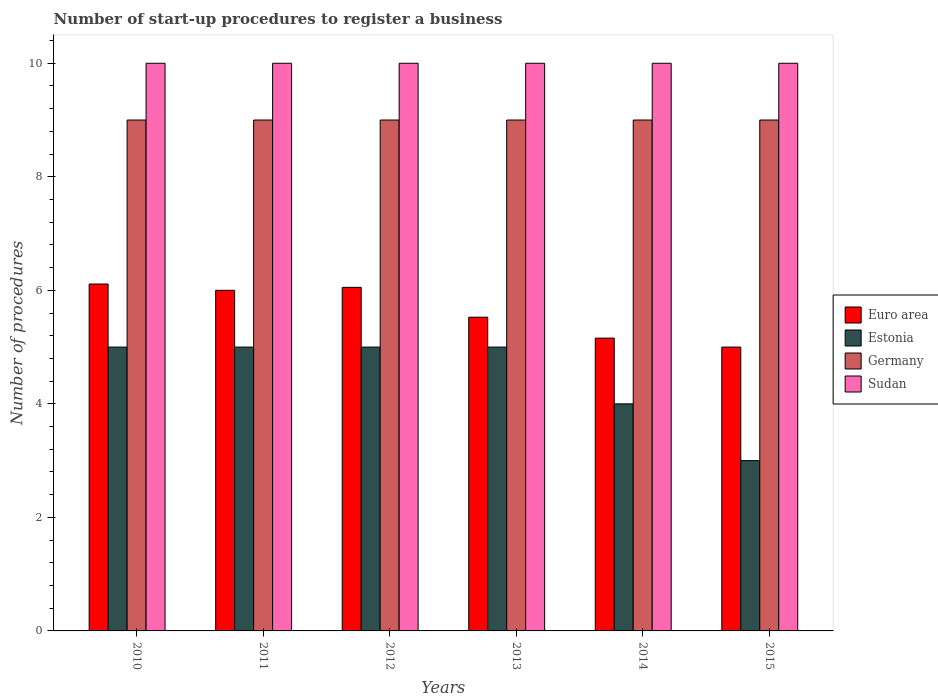How many different coloured bars are there?
Provide a succinct answer. 4. How many groups of bars are there?
Your response must be concise. 6. How many bars are there on the 1st tick from the right?
Ensure brevity in your answer.  4. What is the label of the 1st group of bars from the left?
Offer a terse response. 2010. What is the number of procedures required to register a business in Germany in 2010?
Ensure brevity in your answer.  9. Across all years, what is the maximum number of procedures required to register a business in Germany?
Your response must be concise. 9. In which year was the number of procedures required to register a business in Euro area minimum?
Provide a short and direct response. 2015. What is the total number of procedures required to register a business in Euro area in the graph?
Offer a terse response. 33.85. What is the difference between the number of procedures required to register a business in Germany in 2011 and that in 2014?
Your answer should be compact. 0. What is the average number of procedures required to register a business in Euro area per year?
Your response must be concise. 5.64. In the year 2014, what is the difference between the number of procedures required to register a business in Sudan and number of procedures required to register a business in Euro area?
Offer a terse response. 4.84. In how many years, is the number of procedures required to register a business in Euro area greater than 4.4?
Offer a very short reply. 6. Is the difference between the number of procedures required to register a business in Sudan in 2012 and 2015 greater than the difference between the number of procedures required to register a business in Euro area in 2012 and 2015?
Offer a terse response. No. What is the difference between the highest and the second highest number of procedures required to register a business in Estonia?
Offer a very short reply. 0. Is the sum of the number of procedures required to register a business in Germany in 2010 and 2011 greater than the maximum number of procedures required to register a business in Sudan across all years?
Offer a terse response. Yes. Is it the case that in every year, the sum of the number of procedures required to register a business in Estonia and number of procedures required to register a business in Germany is greater than the sum of number of procedures required to register a business in Euro area and number of procedures required to register a business in Sudan?
Offer a very short reply. Yes. Is it the case that in every year, the sum of the number of procedures required to register a business in Estonia and number of procedures required to register a business in Germany is greater than the number of procedures required to register a business in Sudan?
Your answer should be compact. Yes. Are all the bars in the graph horizontal?
Keep it short and to the point. No. How many years are there in the graph?
Your answer should be very brief. 6. Are the values on the major ticks of Y-axis written in scientific E-notation?
Keep it short and to the point. No. Does the graph contain grids?
Give a very brief answer. No. How many legend labels are there?
Offer a very short reply. 4. What is the title of the graph?
Provide a short and direct response. Number of start-up procedures to register a business. Does "Yemen, Rep." appear as one of the legend labels in the graph?
Your response must be concise. No. What is the label or title of the Y-axis?
Give a very brief answer. Number of procedures. What is the Number of procedures in Euro area in 2010?
Provide a succinct answer. 6.11. What is the Number of procedures of Germany in 2010?
Keep it short and to the point. 9. What is the Number of procedures in Estonia in 2011?
Your answer should be very brief. 5. What is the Number of procedures of Germany in 2011?
Ensure brevity in your answer.  9. What is the Number of procedures of Sudan in 2011?
Offer a terse response. 10. What is the Number of procedures in Euro area in 2012?
Make the answer very short. 6.05. What is the Number of procedures of Estonia in 2012?
Offer a terse response. 5. What is the Number of procedures of Sudan in 2012?
Your answer should be very brief. 10. What is the Number of procedures of Euro area in 2013?
Offer a very short reply. 5.53. What is the Number of procedures in Estonia in 2013?
Offer a terse response. 5. What is the Number of procedures in Germany in 2013?
Provide a short and direct response. 9. What is the Number of procedures in Euro area in 2014?
Keep it short and to the point. 5.16. What is the Number of procedures in Germany in 2014?
Offer a very short reply. 9. What is the Number of procedures in Sudan in 2014?
Give a very brief answer. 10. What is the Number of procedures in Euro area in 2015?
Your answer should be very brief. 5. What is the Number of procedures of Estonia in 2015?
Provide a succinct answer. 3. What is the Number of procedures of Germany in 2015?
Make the answer very short. 9. Across all years, what is the maximum Number of procedures of Euro area?
Provide a short and direct response. 6.11. Across all years, what is the maximum Number of procedures of Estonia?
Ensure brevity in your answer.  5. Across all years, what is the maximum Number of procedures of Germany?
Offer a terse response. 9. Across all years, what is the maximum Number of procedures in Sudan?
Keep it short and to the point. 10. Across all years, what is the minimum Number of procedures in Sudan?
Offer a terse response. 10. What is the total Number of procedures of Euro area in the graph?
Provide a succinct answer. 33.85. What is the total Number of procedures in Estonia in the graph?
Ensure brevity in your answer.  27. What is the total Number of procedures of Sudan in the graph?
Make the answer very short. 60. What is the difference between the Number of procedures of Sudan in 2010 and that in 2011?
Your response must be concise. 0. What is the difference between the Number of procedures in Euro area in 2010 and that in 2012?
Make the answer very short. 0.06. What is the difference between the Number of procedures in Estonia in 2010 and that in 2012?
Offer a very short reply. 0. What is the difference between the Number of procedures in Sudan in 2010 and that in 2012?
Offer a terse response. 0. What is the difference between the Number of procedures of Euro area in 2010 and that in 2013?
Provide a short and direct response. 0.58. What is the difference between the Number of procedures of Germany in 2010 and that in 2013?
Make the answer very short. 0. What is the difference between the Number of procedures of Euro area in 2010 and that in 2014?
Provide a short and direct response. 0.95. What is the difference between the Number of procedures of Estonia in 2010 and that in 2014?
Your answer should be compact. 1. What is the difference between the Number of procedures in Germany in 2010 and that in 2014?
Provide a succinct answer. 0. What is the difference between the Number of procedures in Estonia in 2010 and that in 2015?
Ensure brevity in your answer.  2. What is the difference between the Number of procedures of Germany in 2010 and that in 2015?
Your answer should be very brief. 0. What is the difference between the Number of procedures in Sudan in 2010 and that in 2015?
Your answer should be very brief. 0. What is the difference between the Number of procedures in Euro area in 2011 and that in 2012?
Provide a succinct answer. -0.05. What is the difference between the Number of procedures in Estonia in 2011 and that in 2012?
Make the answer very short. 0. What is the difference between the Number of procedures in Germany in 2011 and that in 2012?
Ensure brevity in your answer.  0. What is the difference between the Number of procedures of Sudan in 2011 and that in 2012?
Keep it short and to the point. 0. What is the difference between the Number of procedures of Euro area in 2011 and that in 2013?
Offer a very short reply. 0.47. What is the difference between the Number of procedures in Sudan in 2011 and that in 2013?
Provide a short and direct response. 0. What is the difference between the Number of procedures of Euro area in 2011 and that in 2014?
Make the answer very short. 0.84. What is the difference between the Number of procedures in Sudan in 2011 and that in 2014?
Give a very brief answer. 0. What is the difference between the Number of procedures of Germany in 2011 and that in 2015?
Provide a succinct answer. 0. What is the difference between the Number of procedures of Euro area in 2012 and that in 2013?
Offer a very short reply. 0.53. What is the difference between the Number of procedures in Germany in 2012 and that in 2013?
Your answer should be very brief. 0. What is the difference between the Number of procedures in Euro area in 2012 and that in 2014?
Offer a very short reply. 0.89. What is the difference between the Number of procedures in Sudan in 2012 and that in 2014?
Ensure brevity in your answer.  0. What is the difference between the Number of procedures in Euro area in 2012 and that in 2015?
Your answer should be very brief. 1.05. What is the difference between the Number of procedures in Estonia in 2012 and that in 2015?
Make the answer very short. 2. What is the difference between the Number of procedures of Euro area in 2013 and that in 2014?
Your response must be concise. 0.37. What is the difference between the Number of procedures of Estonia in 2013 and that in 2014?
Your answer should be very brief. 1. What is the difference between the Number of procedures in Sudan in 2013 and that in 2014?
Your answer should be compact. 0. What is the difference between the Number of procedures of Euro area in 2013 and that in 2015?
Ensure brevity in your answer.  0.53. What is the difference between the Number of procedures in Estonia in 2013 and that in 2015?
Provide a short and direct response. 2. What is the difference between the Number of procedures of Germany in 2013 and that in 2015?
Offer a terse response. 0. What is the difference between the Number of procedures of Euro area in 2014 and that in 2015?
Offer a terse response. 0.16. What is the difference between the Number of procedures of Sudan in 2014 and that in 2015?
Offer a terse response. 0. What is the difference between the Number of procedures of Euro area in 2010 and the Number of procedures of Germany in 2011?
Offer a terse response. -2.89. What is the difference between the Number of procedures in Euro area in 2010 and the Number of procedures in Sudan in 2011?
Offer a terse response. -3.89. What is the difference between the Number of procedures of Estonia in 2010 and the Number of procedures of Sudan in 2011?
Make the answer very short. -5. What is the difference between the Number of procedures in Germany in 2010 and the Number of procedures in Sudan in 2011?
Keep it short and to the point. -1. What is the difference between the Number of procedures of Euro area in 2010 and the Number of procedures of Estonia in 2012?
Provide a short and direct response. 1.11. What is the difference between the Number of procedures in Euro area in 2010 and the Number of procedures in Germany in 2012?
Ensure brevity in your answer.  -2.89. What is the difference between the Number of procedures of Euro area in 2010 and the Number of procedures of Sudan in 2012?
Ensure brevity in your answer.  -3.89. What is the difference between the Number of procedures in Estonia in 2010 and the Number of procedures in Sudan in 2012?
Offer a very short reply. -5. What is the difference between the Number of procedures in Germany in 2010 and the Number of procedures in Sudan in 2012?
Offer a very short reply. -1. What is the difference between the Number of procedures of Euro area in 2010 and the Number of procedures of Germany in 2013?
Offer a terse response. -2.89. What is the difference between the Number of procedures of Euro area in 2010 and the Number of procedures of Sudan in 2013?
Make the answer very short. -3.89. What is the difference between the Number of procedures in Euro area in 2010 and the Number of procedures in Estonia in 2014?
Your answer should be very brief. 2.11. What is the difference between the Number of procedures of Euro area in 2010 and the Number of procedures of Germany in 2014?
Offer a very short reply. -2.89. What is the difference between the Number of procedures in Euro area in 2010 and the Number of procedures in Sudan in 2014?
Provide a short and direct response. -3.89. What is the difference between the Number of procedures in Estonia in 2010 and the Number of procedures in Sudan in 2014?
Make the answer very short. -5. What is the difference between the Number of procedures of Euro area in 2010 and the Number of procedures of Estonia in 2015?
Provide a succinct answer. 3.11. What is the difference between the Number of procedures in Euro area in 2010 and the Number of procedures in Germany in 2015?
Your response must be concise. -2.89. What is the difference between the Number of procedures in Euro area in 2010 and the Number of procedures in Sudan in 2015?
Provide a short and direct response. -3.89. What is the difference between the Number of procedures of Estonia in 2010 and the Number of procedures of Sudan in 2015?
Ensure brevity in your answer.  -5. What is the difference between the Number of procedures of Euro area in 2011 and the Number of procedures of Estonia in 2012?
Give a very brief answer. 1. What is the difference between the Number of procedures in Euro area in 2011 and the Number of procedures in Germany in 2012?
Offer a very short reply. -3. What is the difference between the Number of procedures of Euro area in 2011 and the Number of procedures of Sudan in 2012?
Make the answer very short. -4. What is the difference between the Number of procedures in Germany in 2011 and the Number of procedures in Sudan in 2012?
Ensure brevity in your answer.  -1. What is the difference between the Number of procedures in Euro area in 2011 and the Number of procedures in Germany in 2013?
Your answer should be very brief. -3. What is the difference between the Number of procedures of Euro area in 2011 and the Number of procedures of Sudan in 2013?
Your answer should be compact. -4. What is the difference between the Number of procedures in Estonia in 2011 and the Number of procedures in Germany in 2013?
Your answer should be compact. -4. What is the difference between the Number of procedures in Estonia in 2011 and the Number of procedures in Sudan in 2013?
Offer a terse response. -5. What is the difference between the Number of procedures in Estonia in 2011 and the Number of procedures in Germany in 2014?
Ensure brevity in your answer.  -4. What is the difference between the Number of procedures in Estonia in 2011 and the Number of procedures in Sudan in 2014?
Give a very brief answer. -5. What is the difference between the Number of procedures in Germany in 2011 and the Number of procedures in Sudan in 2014?
Give a very brief answer. -1. What is the difference between the Number of procedures in Euro area in 2011 and the Number of procedures in Estonia in 2015?
Keep it short and to the point. 3. What is the difference between the Number of procedures in Euro area in 2011 and the Number of procedures in Germany in 2015?
Offer a very short reply. -3. What is the difference between the Number of procedures in Euro area in 2011 and the Number of procedures in Sudan in 2015?
Provide a short and direct response. -4. What is the difference between the Number of procedures of Estonia in 2011 and the Number of procedures of Sudan in 2015?
Keep it short and to the point. -5. What is the difference between the Number of procedures in Euro area in 2012 and the Number of procedures in Estonia in 2013?
Your answer should be very brief. 1.05. What is the difference between the Number of procedures of Euro area in 2012 and the Number of procedures of Germany in 2013?
Offer a very short reply. -2.95. What is the difference between the Number of procedures of Euro area in 2012 and the Number of procedures of Sudan in 2013?
Give a very brief answer. -3.95. What is the difference between the Number of procedures of Estonia in 2012 and the Number of procedures of Sudan in 2013?
Your answer should be compact. -5. What is the difference between the Number of procedures in Euro area in 2012 and the Number of procedures in Estonia in 2014?
Ensure brevity in your answer.  2.05. What is the difference between the Number of procedures in Euro area in 2012 and the Number of procedures in Germany in 2014?
Provide a short and direct response. -2.95. What is the difference between the Number of procedures in Euro area in 2012 and the Number of procedures in Sudan in 2014?
Keep it short and to the point. -3.95. What is the difference between the Number of procedures of Euro area in 2012 and the Number of procedures of Estonia in 2015?
Give a very brief answer. 3.05. What is the difference between the Number of procedures of Euro area in 2012 and the Number of procedures of Germany in 2015?
Your answer should be very brief. -2.95. What is the difference between the Number of procedures in Euro area in 2012 and the Number of procedures in Sudan in 2015?
Keep it short and to the point. -3.95. What is the difference between the Number of procedures of Euro area in 2013 and the Number of procedures of Estonia in 2014?
Offer a terse response. 1.53. What is the difference between the Number of procedures of Euro area in 2013 and the Number of procedures of Germany in 2014?
Your answer should be very brief. -3.47. What is the difference between the Number of procedures in Euro area in 2013 and the Number of procedures in Sudan in 2014?
Offer a terse response. -4.47. What is the difference between the Number of procedures in Euro area in 2013 and the Number of procedures in Estonia in 2015?
Your response must be concise. 2.53. What is the difference between the Number of procedures of Euro area in 2013 and the Number of procedures of Germany in 2015?
Ensure brevity in your answer.  -3.47. What is the difference between the Number of procedures in Euro area in 2013 and the Number of procedures in Sudan in 2015?
Your response must be concise. -4.47. What is the difference between the Number of procedures in Estonia in 2013 and the Number of procedures in Germany in 2015?
Provide a short and direct response. -4. What is the difference between the Number of procedures of Estonia in 2013 and the Number of procedures of Sudan in 2015?
Provide a succinct answer. -5. What is the difference between the Number of procedures in Germany in 2013 and the Number of procedures in Sudan in 2015?
Keep it short and to the point. -1. What is the difference between the Number of procedures in Euro area in 2014 and the Number of procedures in Estonia in 2015?
Make the answer very short. 2.16. What is the difference between the Number of procedures in Euro area in 2014 and the Number of procedures in Germany in 2015?
Your response must be concise. -3.84. What is the difference between the Number of procedures in Euro area in 2014 and the Number of procedures in Sudan in 2015?
Your answer should be compact. -4.84. What is the average Number of procedures of Euro area per year?
Make the answer very short. 5.64. What is the average Number of procedures in Germany per year?
Your answer should be very brief. 9. In the year 2010, what is the difference between the Number of procedures in Euro area and Number of procedures in Estonia?
Your answer should be very brief. 1.11. In the year 2010, what is the difference between the Number of procedures in Euro area and Number of procedures in Germany?
Provide a short and direct response. -2.89. In the year 2010, what is the difference between the Number of procedures in Euro area and Number of procedures in Sudan?
Offer a terse response. -3.89. In the year 2010, what is the difference between the Number of procedures of Estonia and Number of procedures of Germany?
Keep it short and to the point. -4. In the year 2011, what is the difference between the Number of procedures in Estonia and Number of procedures in Germany?
Your answer should be compact. -4. In the year 2011, what is the difference between the Number of procedures of Estonia and Number of procedures of Sudan?
Keep it short and to the point. -5. In the year 2011, what is the difference between the Number of procedures in Germany and Number of procedures in Sudan?
Offer a terse response. -1. In the year 2012, what is the difference between the Number of procedures of Euro area and Number of procedures of Estonia?
Provide a short and direct response. 1.05. In the year 2012, what is the difference between the Number of procedures in Euro area and Number of procedures in Germany?
Your response must be concise. -2.95. In the year 2012, what is the difference between the Number of procedures in Euro area and Number of procedures in Sudan?
Your answer should be very brief. -3.95. In the year 2012, what is the difference between the Number of procedures in Estonia and Number of procedures in Sudan?
Provide a short and direct response. -5. In the year 2013, what is the difference between the Number of procedures in Euro area and Number of procedures in Estonia?
Your response must be concise. 0.53. In the year 2013, what is the difference between the Number of procedures in Euro area and Number of procedures in Germany?
Your response must be concise. -3.47. In the year 2013, what is the difference between the Number of procedures of Euro area and Number of procedures of Sudan?
Your answer should be very brief. -4.47. In the year 2013, what is the difference between the Number of procedures in Estonia and Number of procedures in Germany?
Make the answer very short. -4. In the year 2013, what is the difference between the Number of procedures of Estonia and Number of procedures of Sudan?
Your answer should be compact. -5. In the year 2013, what is the difference between the Number of procedures of Germany and Number of procedures of Sudan?
Offer a terse response. -1. In the year 2014, what is the difference between the Number of procedures of Euro area and Number of procedures of Estonia?
Your answer should be compact. 1.16. In the year 2014, what is the difference between the Number of procedures of Euro area and Number of procedures of Germany?
Provide a short and direct response. -3.84. In the year 2014, what is the difference between the Number of procedures in Euro area and Number of procedures in Sudan?
Provide a succinct answer. -4.84. In the year 2014, what is the difference between the Number of procedures in Estonia and Number of procedures in Sudan?
Keep it short and to the point. -6. In the year 2014, what is the difference between the Number of procedures of Germany and Number of procedures of Sudan?
Give a very brief answer. -1. In the year 2015, what is the difference between the Number of procedures in Euro area and Number of procedures in Estonia?
Offer a very short reply. 2. In the year 2015, what is the difference between the Number of procedures in Euro area and Number of procedures in Sudan?
Offer a very short reply. -5. In the year 2015, what is the difference between the Number of procedures of Germany and Number of procedures of Sudan?
Make the answer very short. -1. What is the ratio of the Number of procedures of Euro area in 2010 to that in 2011?
Your answer should be compact. 1.02. What is the ratio of the Number of procedures of Estonia in 2010 to that in 2011?
Provide a succinct answer. 1. What is the ratio of the Number of procedures in Sudan in 2010 to that in 2011?
Your answer should be very brief. 1. What is the ratio of the Number of procedures in Euro area in 2010 to that in 2012?
Your response must be concise. 1.01. What is the ratio of the Number of procedures in Estonia in 2010 to that in 2012?
Your answer should be very brief. 1. What is the ratio of the Number of procedures in Sudan in 2010 to that in 2012?
Give a very brief answer. 1. What is the ratio of the Number of procedures in Euro area in 2010 to that in 2013?
Provide a succinct answer. 1.11. What is the ratio of the Number of procedures of Germany in 2010 to that in 2013?
Your answer should be very brief. 1. What is the ratio of the Number of procedures in Euro area in 2010 to that in 2014?
Offer a terse response. 1.18. What is the ratio of the Number of procedures in Estonia in 2010 to that in 2014?
Your response must be concise. 1.25. What is the ratio of the Number of procedures in Germany in 2010 to that in 2014?
Offer a very short reply. 1. What is the ratio of the Number of procedures in Sudan in 2010 to that in 2014?
Give a very brief answer. 1. What is the ratio of the Number of procedures of Euro area in 2010 to that in 2015?
Offer a terse response. 1.22. What is the ratio of the Number of procedures in Estonia in 2010 to that in 2015?
Provide a succinct answer. 1.67. What is the ratio of the Number of procedures of Germany in 2010 to that in 2015?
Your response must be concise. 1. What is the ratio of the Number of procedures in Germany in 2011 to that in 2012?
Provide a succinct answer. 1. What is the ratio of the Number of procedures of Sudan in 2011 to that in 2012?
Your answer should be compact. 1. What is the ratio of the Number of procedures of Euro area in 2011 to that in 2013?
Your answer should be very brief. 1.09. What is the ratio of the Number of procedures of Estonia in 2011 to that in 2013?
Provide a succinct answer. 1. What is the ratio of the Number of procedures in Germany in 2011 to that in 2013?
Offer a very short reply. 1. What is the ratio of the Number of procedures of Sudan in 2011 to that in 2013?
Offer a very short reply. 1. What is the ratio of the Number of procedures in Euro area in 2011 to that in 2014?
Provide a short and direct response. 1.16. What is the ratio of the Number of procedures of Estonia in 2011 to that in 2015?
Your answer should be compact. 1.67. What is the ratio of the Number of procedures of Euro area in 2012 to that in 2013?
Provide a short and direct response. 1.1. What is the ratio of the Number of procedures of Estonia in 2012 to that in 2013?
Your answer should be compact. 1. What is the ratio of the Number of procedures in Euro area in 2012 to that in 2014?
Your answer should be compact. 1.17. What is the ratio of the Number of procedures of Germany in 2012 to that in 2014?
Give a very brief answer. 1. What is the ratio of the Number of procedures of Euro area in 2012 to that in 2015?
Offer a terse response. 1.21. What is the ratio of the Number of procedures of Estonia in 2012 to that in 2015?
Offer a very short reply. 1.67. What is the ratio of the Number of procedures of Germany in 2012 to that in 2015?
Provide a succinct answer. 1. What is the ratio of the Number of procedures of Euro area in 2013 to that in 2014?
Keep it short and to the point. 1.07. What is the ratio of the Number of procedures of Germany in 2013 to that in 2014?
Your answer should be compact. 1. What is the ratio of the Number of procedures of Sudan in 2013 to that in 2014?
Provide a short and direct response. 1. What is the ratio of the Number of procedures in Euro area in 2013 to that in 2015?
Keep it short and to the point. 1.11. What is the ratio of the Number of procedures in Estonia in 2013 to that in 2015?
Provide a short and direct response. 1.67. What is the ratio of the Number of procedures in Euro area in 2014 to that in 2015?
Your answer should be very brief. 1.03. What is the ratio of the Number of procedures of Germany in 2014 to that in 2015?
Your response must be concise. 1. What is the ratio of the Number of procedures in Sudan in 2014 to that in 2015?
Give a very brief answer. 1. What is the difference between the highest and the second highest Number of procedures of Euro area?
Make the answer very short. 0.06. What is the difference between the highest and the second highest Number of procedures of Germany?
Ensure brevity in your answer.  0. What is the difference between the highest and the second highest Number of procedures in Sudan?
Give a very brief answer. 0. What is the difference between the highest and the lowest Number of procedures of Estonia?
Keep it short and to the point. 2. What is the difference between the highest and the lowest Number of procedures in Germany?
Your answer should be compact. 0. 